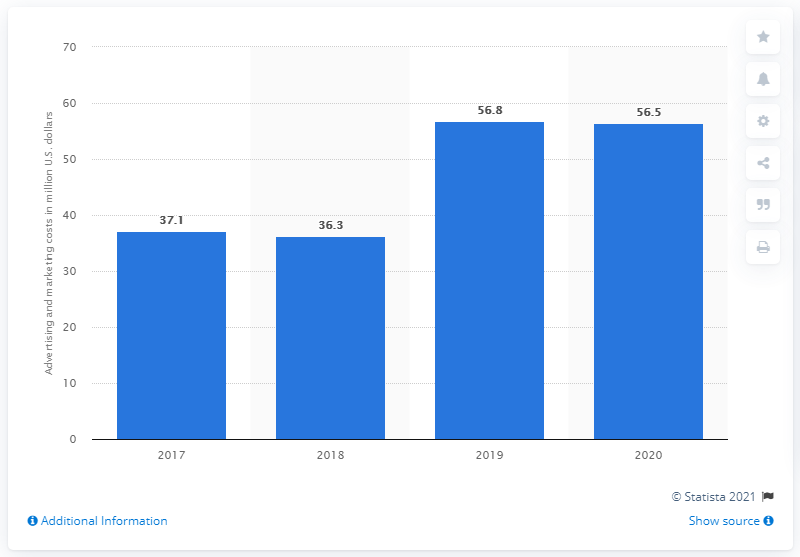List a handful of essential elements in this visual. Guess's advertising and marketing expenses in 2020 totaled $56.5 million. The company's advertising and marketing expenses in the previous year were $56.5 million. 